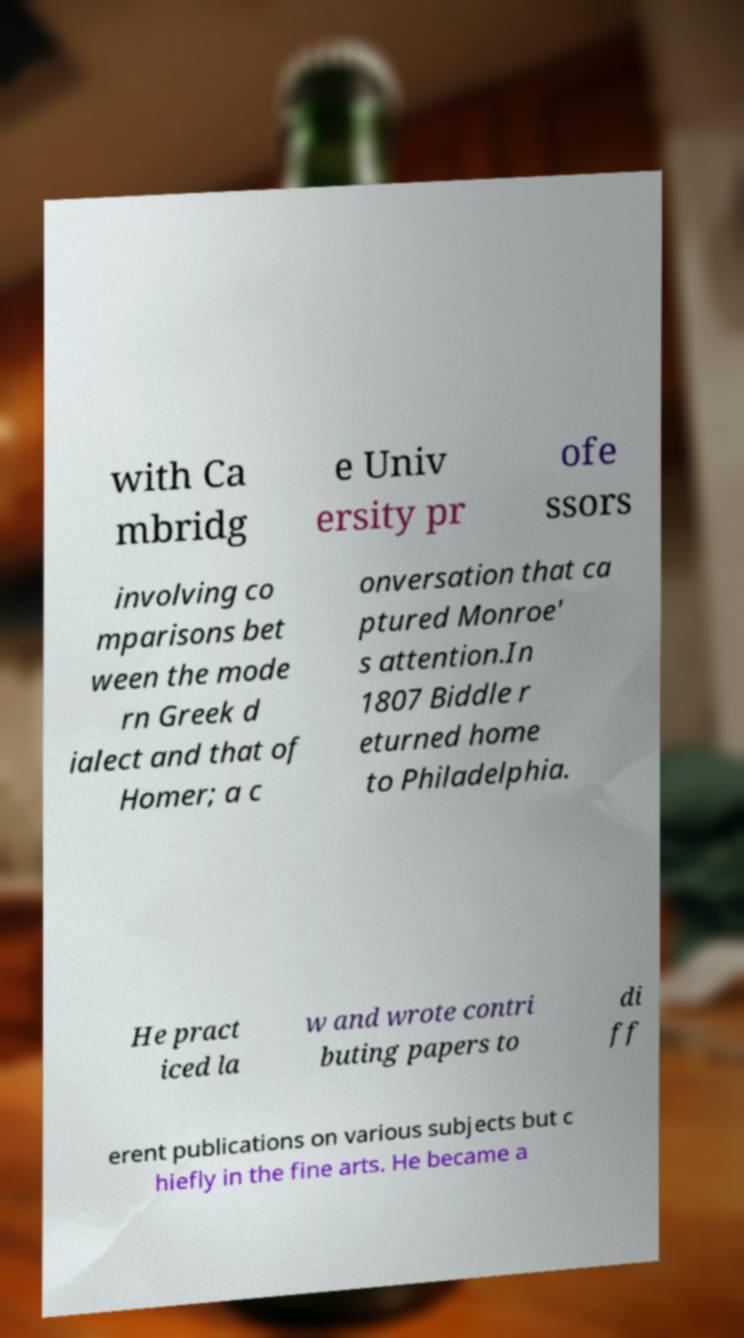Can you read and provide the text displayed in the image?This photo seems to have some interesting text. Can you extract and type it out for me? with Ca mbridg e Univ ersity pr ofe ssors involving co mparisons bet ween the mode rn Greek d ialect and that of Homer; a c onversation that ca ptured Monroe' s attention.In 1807 Biddle r eturned home to Philadelphia. He pract iced la w and wrote contri buting papers to di ff erent publications on various subjects but c hiefly in the fine arts. He became a 